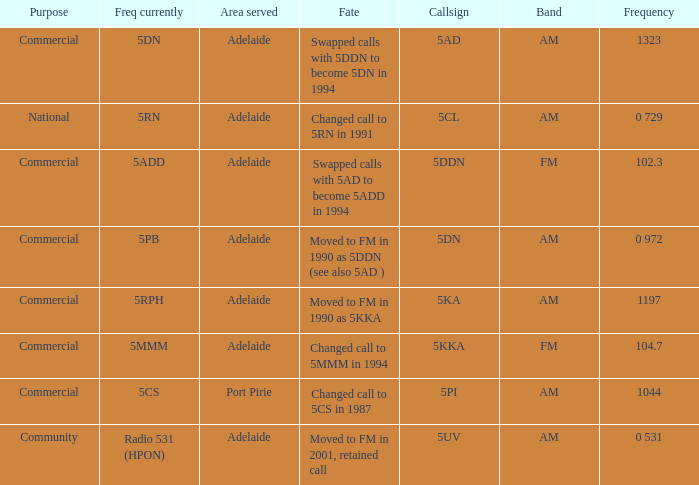What is the purpose for Frequency of 102.3? Commercial. 